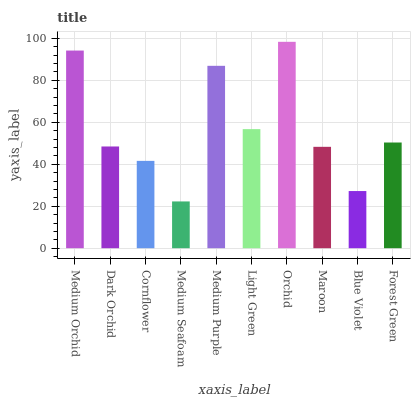Is Dark Orchid the minimum?
Answer yes or no. No. Is Dark Orchid the maximum?
Answer yes or no. No. Is Medium Orchid greater than Dark Orchid?
Answer yes or no. Yes. Is Dark Orchid less than Medium Orchid?
Answer yes or no. Yes. Is Dark Orchid greater than Medium Orchid?
Answer yes or no. No. Is Medium Orchid less than Dark Orchid?
Answer yes or no. No. Is Forest Green the high median?
Answer yes or no. Yes. Is Dark Orchid the low median?
Answer yes or no. Yes. Is Light Green the high median?
Answer yes or no. No. Is Orchid the low median?
Answer yes or no. No. 